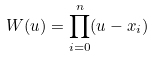Convert formula to latex. <formula><loc_0><loc_0><loc_500><loc_500>W ( u ) = \prod _ { i = 0 } ^ { n } ( u - x _ { i } )</formula> 